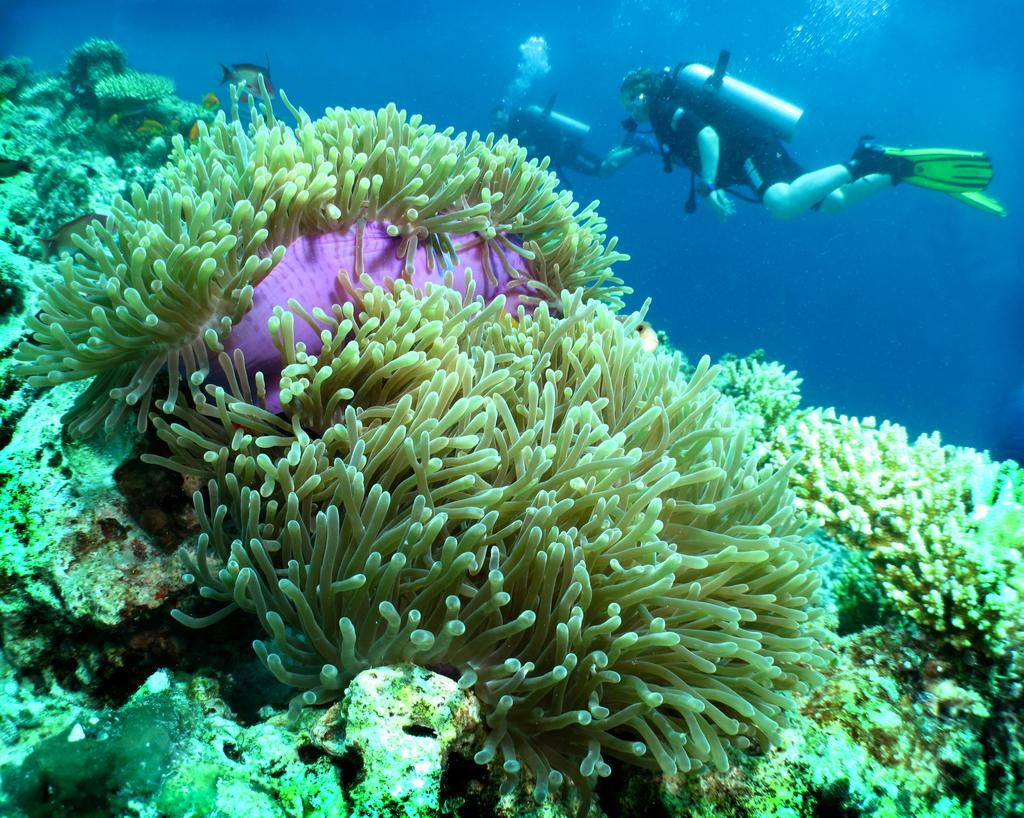What type of natural formation can be seen in the image? There is coral in the image. Who is present in the water in the image? There are two people in the water. What are the people wearing on their feet? The people are wearing training fins. Can you describe any objects visible in the image? There are some objects in the image. What type of power source is visible in the image? There is no power source visible in the image; it features coral and people in the water. Can you tell me how many cups are present in the image? There is no cup present in the image. 